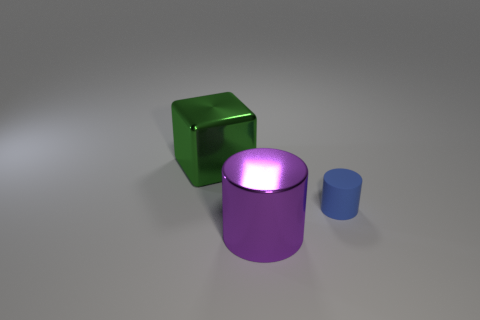Add 3 large red spheres. How many objects exist? 6 Subtract all cylinders. How many objects are left? 1 Subtract 0 blue balls. How many objects are left? 3 Subtract all big green cubes. Subtract all big purple things. How many objects are left? 1 Add 2 purple cylinders. How many purple cylinders are left? 3 Add 1 matte things. How many matte things exist? 2 